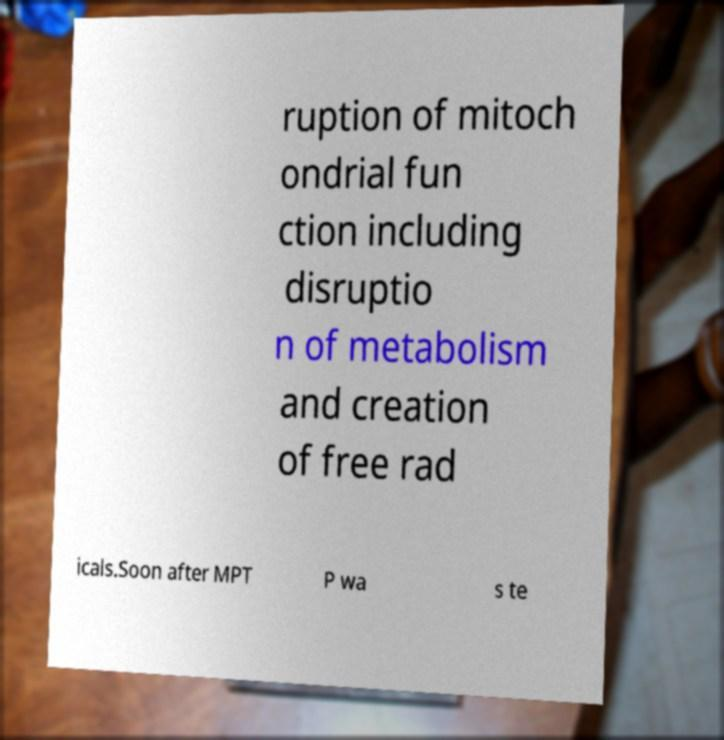Please identify and transcribe the text found in this image. ruption of mitoch ondrial fun ction including disruptio n of metabolism and creation of free rad icals.Soon after MPT P wa s te 